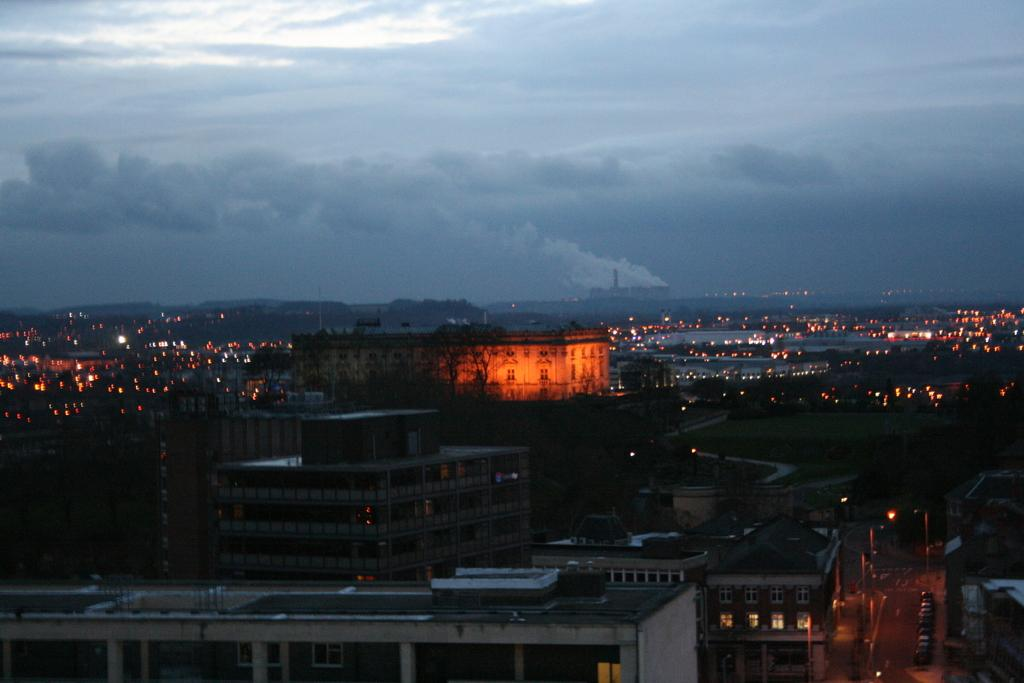What type of structures can be seen in the image? There are buildings in the image. Are there any illuminated objects or areas in the image? Yes, there are lights visible in the image. How would you describe the sky in the background of the image? The sky in the background is cloudy. How many clovers can be found growing near the buildings in the image? There are no clovers visible in the image; it only features buildings, lights, and a cloudy sky. 